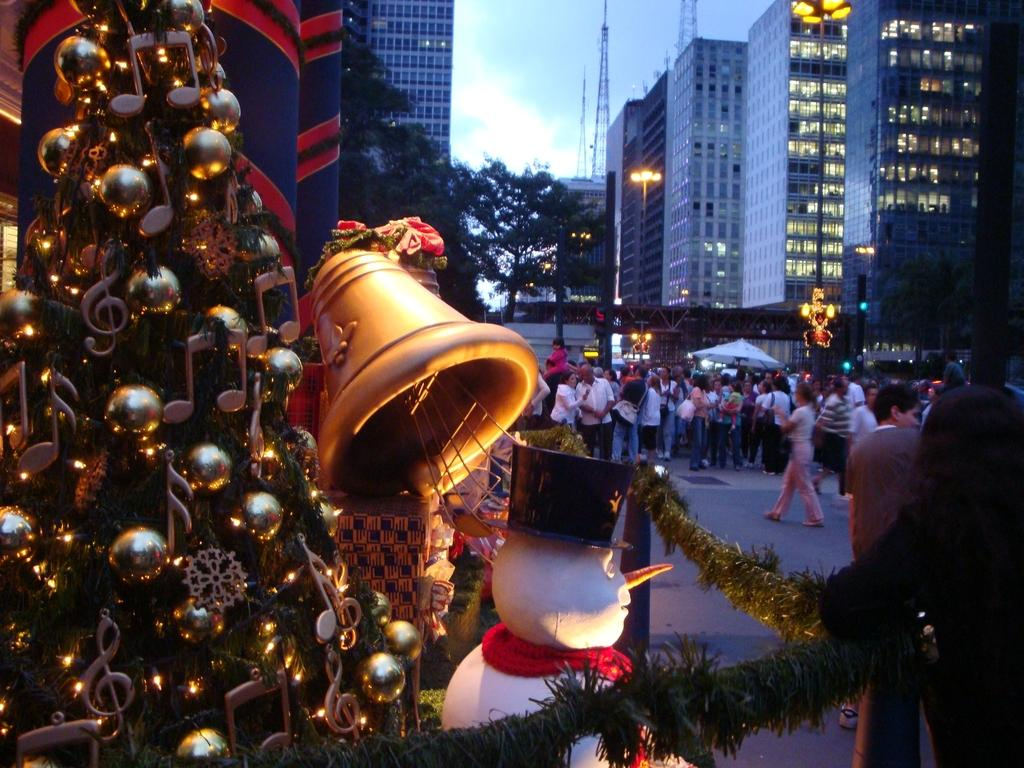What type of structures can be seen in the image? There are many buildings in the image. Are there any natural elements present in the image? Yes, there is a tree in the image. What is located on the left side of the image? There is a Xmas tree on the left side of the image. What can be seen in the middle of the image? There are many people on the road in the middle of the image. What is at the bottom of the image? There is a road at the bottom of the image. Can you see a kitten playing with a drum made of metal in the image? No, there is no kitten or drum made of metal present in the image. 